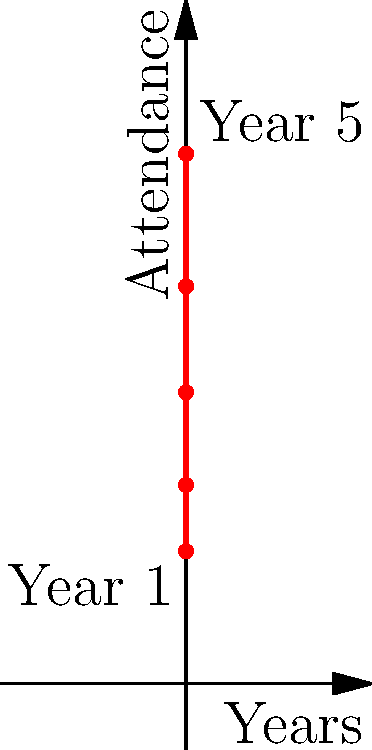The graph shows the attendance at your favorite boy band's concerts over the past 5 years. Assuming the trend continues, predict the attendance for their concert in Year 7. Round your answer to the nearest thousand. To solve this problem, we need to:

1. Identify the trend in the data:
   Year 1: 10,000
   Year 5: 40,000

2. Calculate the average increase per year:
   $\frac{40,000 - 10,000}{5 - 1} = \frac{30,000}{4} = 7,500$ attendees per year

3. Extend this trend for 2 more years (to Year 7):
   Year 5 attendance: 40,000
   Year 6 predicted: $40,000 + 7,500 = 47,500$
   Year 7 predicted: $47,500 + 7,500 = 55,000$

4. Round to the nearest thousand:
   55,000 (already rounded)

Therefore, the predicted attendance for Year 7 is 55,000.
Answer: 55,000 